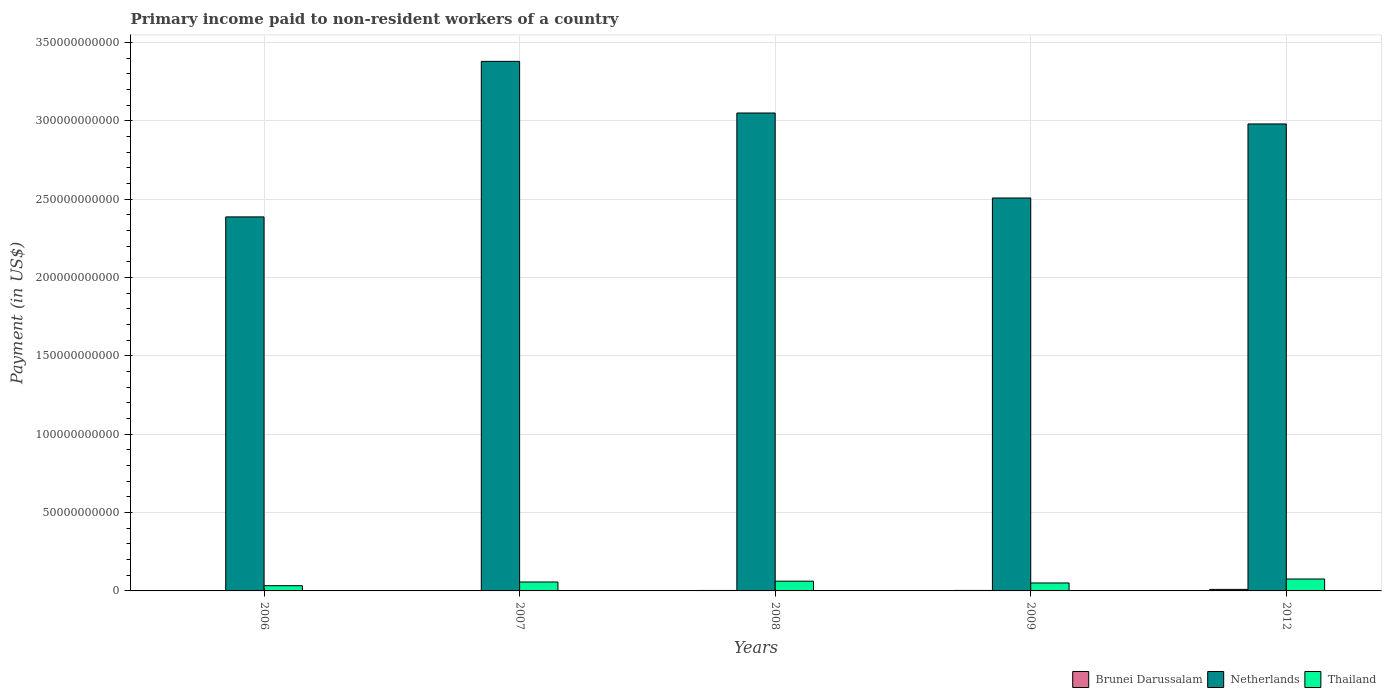How many different coloured bars are there?
Provide a succinct answer. 3. Are the number of bars per tick equal to the number of legend labels?
Provide a succinct answer. Yes. Are the number of bars on each tick of the X-axis equal?
Your answer should be compact. Yes. How many bars are there on the 1st tick from the left?
Make the answer very short. 3. What is the label of the 2nd group of bars from the left?
Offer a terse response. 2007. In how many cases, is the number of bars for a given year not equal to the number of legend labels?
Make the answer very short. 0. What is the amount paid to workers in Brunei Darussalam in 2012?
Your answer should be compact. 9.74e+08. Across all years, what is the maximum amount paid to workers in Netherlands?
Ensure brevity in your answer.  3.38e+11. Across all years, what is the minimum amount paid to workers in Netherlands?
Make the answer very short. 2.39e+11. In which year was the amount paid to workers in Thailand maximum?
Make the answer very short. 2012. What is the total amount paid to workers in Netherlands in the graph?
Provide a short and direct response. 1.43e+12. What is the difference between the amount paid to workers in Brunei Darussalam in 2006 and that in 2009?
Your answer should be compact. -6.83e+07. What is the difference between the amount paid to workers in Thailand in 2007 and the amount paid to workers in Brunei Darussalam in 2006?
Keep it short and to the point. 5.45e+09. What is the average amount paid to workers in Brunei Darussalam per year?
Make the answer very short. 4.22e+08. In the year 2012, what is the difference between the amount paid to workers in Brunei Darussalam and amount paid to workers in Netherlands?
Give a very brief answer. -2.97e+11. What is the ratio of the amount paid to workers in Thailand in 2007 to that in 2012?
Your answer should be very brief. 0.75. Is the difference between the amount paid to workers in Brunei Darussalam in 2009 and 2012 greater than the difference between the amount paid to workers in Netherlands in 2009 and 2012?
Provide a succinct answer. Yes. What is the difference between the highest and the second highest amount paid to workers in Netherlands?
Give a very brief answer. 3.30e+1. What is the difference between the highest and the lowest amount paid to workers in Brunei Darussalam?
Provide a succinct answer. 7.27e+08. What does the 1st bar from the right in 2012 represents?
Ensure brevity in your answer.  Thailand. How many bars are there?
Ensure brevity in your answer.  15. How many years are there in the graph?
Give a very brief answer. 5. Does the graph contain any zero values?
Provide a succinct answer. No. Does the graph contain grids?
Your response must be concise. Yes. What is the title of the graph?
Your answer should be compact. Primary income paid to non-resident workers of a country. What is the label or title of the Y-axis?
Offer a very short reply. Payment (in US$). What is the Payment (in US$) of Brunei Darussalam in 2006?
Your response must be concise. 2.48e+08. What is the Payment (in US$) of Netherlands in 2006?
Your response must be concise. 2.39e+11. What is the Payment (in US$) in Thailand in 2006?
Give a very brief answer. 3.33e+09. What is the Payment (in US$) in Brunei Darussalam in 2007?
Provide a short and direct response. 2.68e+08. What is the Payment (in US$) in Netherlands in 2007?
Your answer should be very brief. 3.38e+11. What is the Payment (in US$) of Thailand in 2007?
Ensure brevity in your answer.  5.70e+09. What is the Payment (in US$) in Brunei Darussalam in 2008?
Offer a terse response. 3.04e+08. What is the Payment (in US$) of Netherlands in 2008?
Offer a very short reply. 3.05e+11. What is the Payment (in US$) in Thailand in 2008?
Keep it short and to the point. 6.21e+09. What is the Payment (in US$) of Brunei Darussalam in 2009?
Make the answer very short. 3.16e+08. What is the Payment (in US$) in Netherlands in 2009?
Offer a terse response. 2.51e+11. What is the Payment (in US$) in Thailand in 2009?
Offer a terse response. 5.08e+09. What is the Payment (in US$) of Brunei Darussalam in 2012?
Your response must be concise. 9.74e+08. What is the Payment (in US$) in Netherlands in 2012?
Your answer should be very brief. 2.98e+11. What is the Payment (in US$) of Thailand in 2012?
Offer a terse response. 7.61e+09. Across all years, what is the maximum Payment (in US$) in Brunei Darussalam?
Offer a terse response. 9.74e+08. Across all years, what is the maximum Payment (in US$) in Netherlands?
Keep it short and to the point. 3.38e+11. Across all years, what is the maximum Payment (in US$) of Thailand?
Your response must be concise. 7.61e+09. Across all years, what is the minimum Payment (in US$) in Brunei Darussalam?
Keep it short and to the point. 2.48e+08. Across all years, what is the minimum Payment (in US$) of Netherlands?
Your answer should be very brief. 2.39e+11. Across all years, what is the minimum Payment (in US$) in Thailand?
Your response must be concise. 3.33e+09. What is the total Payment (in US$) of Brunei Darussalam in the graph?
Ensure brevity in your answer.  2.11e+09. What is the total Payment (in US$) of Netherlands in the graph?
Offer a very short reply. 1.43e+12. What is the total Payment (in US$) in Thailand in the graph?
Your answer should be compact. 2.79e+1. What is the difference between the Payment (in US$) of Brunei Darussalam in 2006 and that in 2007?
Your answer should be very brief. -2.03e+07. What is the difference between the Payment (in US$) in Netherlands in 2006 and that in 2007?
Ensure brevity in your answer.  -9.93e+1. What is the difference between the Payment (in US$) of Thailand in 2006 and that in 2007?
Your response must be concise. -2.37e+09. What is the difference between the Payment (in US$) of Brunei Darussalam in 2006 and that in 2008?
Your response must be concise. -5.57e+07. What is the difference between the Payment (in US$) of Netherlands in 2006 and that in 2008?
Give a very brief answer. -6.63e+1. What is the difference between the Payment (in US$) of Thailand in 2006 and that in 2008?
Make the answer very short. -2.88e+09. What is the difference between the Payment (in US$) of Brunei Darussalam in 2006 and that in 2009?
Offer a very short reply. -6.83e+07. What is the difference between the Payment (in US$) in Netherlands in 2006 and that in 2009?
Make the answer very short. -1.21e+1. What is the difference between the Payment (in US$) in Thailand in 2006 and that in 2009?
Provide a short and direct response. -1.75e+09. What is the difference between the Payment (in US$) in Brunei Darussalam in 2006 and that in 2012?
Offer a very short reply. -7.27e+08. What is the difference between the Payment (in US$) of Netherlands in 2006 and that in 2012?
Your answer should be compact. -5.93e+1. What is the difference between the Payment (in US$) of Thailand in 2006 and that in 2012?
Your answer should be compact. -4.28e+09. What is the difference between the Payment (in US$) in Brunei Darussalam in 2007 and that in 2008?
Your answer should be compact. -3.53e+07. What is the difference between the Payment (in US$) of Netherlands in 2007 and that in 2008?
Offer a very short reply. 3.30e+1. What is the difference between the Payment (in US$) of Thailand in 2007 and that in 2008?
Make the answer very short. -5.16e+08. What is the difference between the Payment (in US$) in Brunei Darussalam in 2007 and that in 2009?
Your answer should be compact. -4.80e+07. What is the difference between the Payment (in US$) in Netherlands in 2007 and that in 2009?
Offer a very short reply. 8.72e+1. What is the difference between the Payment (in US$) in Thailand in 2007 and that in 2009?
Make the answer very short. 6.14e+08. What is the difference between the Payment (in US$) in Brunei Darussalam in 2007 and that in 2012?
Offer a very short reply. -7.06e+08. What is the difference between the Payment (in US$) of Netherlands in 2007 and that in 2012?
Your response must be concise. 4.00e+1. What is the difference between the Payment (in US$) of Thailand in 2007 and that in 2012?
Your answer should be compact. -1.91e+09. What is the difference between the Payment (in US$) in Brunei Darussalam in 2008 and that in 2009?
Give a very brief answer. -1.27e+07. What is the difference between the Payment (in US$) of Netherlands in 2008 and that in 2009?
Provide a short and direct response. 5.42e+1. What is the difference between the Payment (in US$) of Thailand in 2008 and that in 2009?
Your answer should be compact. 1.13e+09. What is the difference between the Payment (in US$) of Brunei Darussalam in 2008 and that in 2012?
Your answer should be very brief. -6.71e+08. What is the difference between the Payment (in US$) of Netherlands in 2008 and that in 2012?
Your answer should be very brief. 6.98e+09. What is the difference between the Payment (in US$) of Thailand in 2008 and that in 2012?
Your answer should be compact. -1.40e+09. What is the difference between the Payment (in US$) in Brunei Darussalam in 2009 and that in 2012?
Your answer should be compact. -6.58e+08. What is the difference between the Payment (in US$) in Netherlands in 2009 and that in 2012?
Provide a succinct answer. -4.73e+1. What is the difference between the Payment (in US$) of Thailand in 2009 and that in 2012?
Make the answer very short. -2.53e+09. What is the difference between the Payment (in US$) in Brunei Darussalam in 2006 and the Payment (in US$) in Netherlands in 2007?
Your response must be concise. -3.38e+11. What is the difference between the Payment (in US$) of Brunei Darussalam in 2006 and the Payment (in US$) of Thailand in 2007?
Offer a very short reply. -5.45e+09. What is the difference between the Payment (in US$) in Netherlands in 2006 and the Payment (in US$) in Thailand in 2007?
Your answer should be very brief. 2.33e+11. What is the difference between the Payment (in US$) in Brunei Darussalam in 2006 and the Payment (in US$) in Netherlands in 2008?
Keep it short and to the point. -3.05e+11. What is the difference between the Payment (in US$) of Brunei Darussalam in 2006 and the Payment (in US$) of Thailand in 2008?
Give a very brief answer. -5.97e+09. What is the difference between the Payment (in US$) of Netherlands in 2006 and the Payment (in US$) of Thailand in 2008?
Give a very brief answer. 2.33e+11. What is the difference between the Payment (in US$) of Brunei Darussalam in 2006 and the Payment (in US$) of Netherlands in 2009?
Offer a very short reply. -2.51e+11. What is the difference between the Payment (in US$) of Brunei Darussalam in 2006 and the Payment (in US$) of Thailand in 2009?
Offer a terse response. -4.84e+09. What is the difference between the Payment (in US$) in Netherlands in 2006 and the Payment (in US$) in Thailand in 2009?
Ensure brevity in your answer.  2.34e+11. What is the difference between the Payment (in US$) of Brunei Darussalam in 2006 and the Payment (in US$) of Netherlands in 2012?
Make the answer very short. -2.98e+11. What is the difference between the Payment (in US$) in Brunei Darussalam in 2006 and the Payment (in US$) in Thailand in 2012?
Provide a short and direct response. -7.36e+09. What is the difference between the Payment (in US$) of Netherlands in 2006 and the Payment (in US$) of Thailand in 2012?
Make the answer very short. 2.31e+11. What is the difference between the Payment (in US$) of Brunei Darussalam in 2007 and the Payment (in US$) of Netherlands in 2008?
Make the answer very short. -3.05e+11. What is the difference between the Payment (in US$) of Brunei Darussalam in 2007 and the Payment (in US$) of Thailand in 2008?
Your answer should be compact. -5.95e+09. What is the difference between the Payment (in US$) of Netherlands in 2007 and the Payment (in US$) of Thailand in 2008?
Provide a short and direct response. 3.32e+11. What is the difference between the Payment (in US$) in Brunei Darussalam in 2007 and the Payment (in US$) in Netherlands in 2009?
Make the answer very short. -2.51e+11. What is the difference between the Payment (in US$) in Brunei Darussalam in 2007 and the Payment (in US$) in Thailand in 2009?
Provide a short and direct response. -4.82e+09. What is the difference between the Payment (in US$) in Netherlands in 2007 and the Payment (in US$) in Thailand in 2009?
Provide a short and direct response. 3.33e+11. What is the difference between the Payment (in US$) of Brunei Darussalam in 2007 and the Payment (in US$) of Netherlands in 2012?
Provide a short and direct response. -2.98e+11. What is the difference between the Payment (in US$) of Brunei Darussalam in 2007 and the Payment (in US$) of Thailand in 2012?
Ensure brevity in your answer.  -7.34e+09. What is the difference between the Payment (in US$) in Netherlands in 2007 and the Payment (in US$) in Thailand in 2012?
Ensure brevity in your answer.  3.30e+11. What is the difference between the Payment (in US$) of Brunei Darussalam in 2008 and the Payment (in US$) of Netherlands in 2009?
Provide a succinct answer. -2.51e+11. What is the difference between the Payment (in US$) of Brunei Darussalam in 2008 and the Payment (in US$) of Thailand in 2009?
Provide a short and direct response. -4.78e+09. What is the difference between the Payment (in US$) of Netherlands in 2008 and the Payment (in US$) of Thailand in 2009?
Ensure brevity in your answer.  3.00e+11. What is the difference between the Payment (in US$) of Brunei Darussalam in 2008 and the Payment (in US$) of Netherlands in 2012?
Offer a terse response. -2.98e+11. What is the difference between the Payment (in US$) of Brunei Darussalam in 2008 and the Payment (in US$) of Thailand in 2012?
Give a very brief answer. -7.31e+09. What is the difference between the Payment (in US$) in Netherlands in 2008 and the Payment (in US$) in Thailand in 2012?
Offer a very short reply. 2.97e+11. What is the difference between the Payment (in US$) in Brunei Darussalam in 2009 and the Payment (in US$) in Netherlands in 2012?
Offer a terse response. -2.98e+11. What is the difference between the Payment (in US$) of Brunei Darussalam in 2009 and the Payment (in US$) of Thailand in 2012?
Offer a very short reply. -7.29e+09. What is the difference between the Payment (in US$) in Netherlands in 2009 and the Payment (in US$) in Thailand in 2012?
Offer a terse response. 2.43e+11. What is the average Payment (in US$) in Brunei Darussalam per year?
Offer a very short reply. 4.22e+08. What is the average Payment (in US$) of Netherlands per year?
Keep it short and to the point. 2.86e+11. What is the average Payment (in US$) in Thailand per year?
Provide a succinct answer. 5.59e+09. In the year 2006, what is the difference between the Payment (in US$) of Brunei Darussalam and Payment (in US$) of Netherlands?
Provide a succinct answer. -2.38e+11. In the year 2006, what is the difference between the Payment (in US$) in Brunei Darussalam and Payment (in US$) in Thailand?
Give a very brief answer. -3.08e+09. In the year 2006, what is the difference between the Payment (in US$) in Netherlands and Payment (in US$) in Thailand?
Give a very brief answer. 2.35e+11. In the year 2007, what is the difference between the Payment (in US$) in Brunei Darussalam and Payment (in US$) in Netherlands?
Offer a very short reply. -3.38e+11. In the year 2007, what is the difference between the Payment (in US$) in Brunei Darussalam and Payment (in US$) in Thailand?
Offer a terse response. -5.43e+09. In the year 2007, what is the difference between the Payment (in US$) of Netherlands and Payment (in US$) of Thailand?
Your response must be concise. 3.32e+11. In the year 2008, what is the difference between the Payment (in US$) of Brunei Darussalam and Payment (in US$) of Netherlands?
Your response must be concise. -3.05e+11. In the year 2008, what is the difference between the Payment (in US$) in Brunei Darussalam and Payment (in US$) in Thailand?
Give a very brief answer. -5.91e+09. In the year 2008, what is the difference between the Payment (in US$) of Netherlands and Payment (in US$) of Thailand?
Make the answer very short. 2.99e+11. In the year 2009, what is the difference between the Payment (in US$) of Brunei Darussalam and Payment (in US$) of Netherlands?
Your response must be concise. -2.51e+11. In the year 2009, what is the difference between the Payment (in US$) of Brunei Darussalam and Payment (in US$) of Thailand?
Your response must be concise. -4.77e+09. In the year 2009, what is the difference between the Payment (in US$) in Netherlands and Payment (in US$) in Thailand?
Provide a succinct answer. 2.46e+11. In the year 2012, what is the difference between the Payment (in US$) in Brunei Darussalam and Payment (in US$) in Netherlands?
Offer a very short reply. -2.97e+11. In the year 2012, what is the difference between the Payment (in US$) in Brunei Darussalam and Payment (in US$) in Thailand?
Your answer should be compact. -6.64e+09. In the year 2012, what is the difference between the Payment (in US$) of Netherlands and Payment (in US$) of Thailand?
Ensure brevity in your answer.  2.90e+11. What is the ratio of the Payment (in US$) in Brunei Darussalam in 2006 to that in 2007?
Ensure brevity in your answer.  0.92. What is the ratio of the Payment (in US$) of Netherlands in 2006 to that in 2007?
Provide a succinct answer. 0.71. What is the ratio of the Payment (in US$) of Thailand in 2006 to that in 2007?
Provide a short and direct response. 0.58. What is the ratio of the Payment (in US$) of Brunei Darussalam in 2006 to that in 2008?
Provide a succinct answer. 0.82. What is the ratio of the Payment (in US$) in Netherlands in 2006 to that in 2008?
Ensure brevity in your answer.  0.78. What is the ratio of the Payment (in US$) in Thailand in 2006 to that in 2008?
Ensure brevity in your answer.  0.54. What is the ratio of the Payment (in US$) of Brunei Darussalam in 2006 to that in 2009?
Provide a succinct answer. 0.78. What is the ratio of the Payment (in US$) in Netherlands in 2006 to that in 2009?
Ensure brevity in your answer.  0.95. What is the ratio of the Payment (in US$) in Thailand in 2006 to that in 2009?
Offer a terse response. 0.66. What is the ratio of the Payment (in US$) in Brunei Darussalam in 2006 to that in 2012?
Offer a terse response. 0.25. What is the ratio of the Payment (in US$) of Netherlands in 2006 to that in 2012?
Offer a terse response. 0.8. What is the ratio of the Payment (in US$) in Thailand in 2006 to that in 2012?
Keep it short and to the point. 0.44. What is the ratio of the Payment (in US$) in Brunei Darussalam in 2007 to that in 2008?
Your answer should be compact. 0.88. What is the ratio of the Payment (in US$) of Netherlands in 2007 to that in 2008?
Your response must be concise. 1.11. What is the ratio of the Payment (in US$) of Thailand in 2007 to that in 2008?
Keep it short and to the point. 0.92. What is the ratio of the Payment (in US$) of Brunei Darussalam in 2007 to that in 2009?
Provide a short and direct response. 0.85. What is the ratio of the Payment (in US$) in Netherlands in 2007 to that in 2009?
Give a very brief answer. 1.35. What is the ratio of the Payment (in US$) in Thailand in 2007 to that in 2009?
Give a very brief answer. 1.12. What is the ratio of the Payment (in US$) in Brunei Darussalam in 2007 to that in 2012?
Ensure brevity in your answer.  0.28. What is the ratio of the Payment (in US$) in Netherlands in 2007 to that in 2012?
Your answer should be very brief. 1.13. What is the ratio of the Payment (in US$) in Thailand in 2007 to that in 2012?
Ensure brevity in your answer.  0.75. What is the ratio of the Payment (in US$) in Brunei Darussalam in 2008 to that in 2009?
Offer a very short reply. 0.96. What is the ratio of the Payment (in US$) of Netherlands in 2008 to that in 2009?
Provide a short and direct response. 1.22. What is the ratio of the Payment (in US$) of Thailand in 2008 to that in 2009?
Keep it short and to the point. 1.22. What is the ratio of the Payment (in US$) in Brunei Darussalam in 2008 to that in 2012?
Keep it short and to the point. 0.31. What is the ratio of the Payment (in US$) in Netherlands in 2008 to that in 2012?
Offer a very short reply. 1.02. What is the ratio of the Payment (in US$) in Thailand in 2008 to that in 2012?
Provide a succinct answer. 0.82. What is the ratio of the Payment (in US$) in Brunei Darussalam in 2009 to that in 2012?
Provide a short and direct response. 0.32. What is the ratio of the Payment (in US$) in Netherlands in 2009 to that in 2012?
Provide a short and direct response. 0.84. What is the ratio of the Payment (in US$) in Thailand in 2009 to that in 2012?
Offer a very short reply. 0.67. What is the difference between the highest and the second highest Payment (in US$) in Brunei Darussalam?
Your answer should be compact. 6.58e+08. What is the difference between the highest and the second highest Payment (in US$) of Netherlands?
Ensure brevity in your answer.  3.30e+1. What is the difference between the highest and the second highest Payment (in US$) in Thailand?
Your answer should be compact. 1.40e+09. What is the difference between the highest and the lowest Payment (in US$) of Brunei Darussalam?
Your response must be concise. 7.27e+08. What is the difference between the highest and the lowest Payment (in US$) of Netherlands?
Make the answer very short. 9.93e+1. What is the difference between the highest and the lowest Payment (in US$) of Thailand?
Keep it short and to the point. 4.28e+09. 